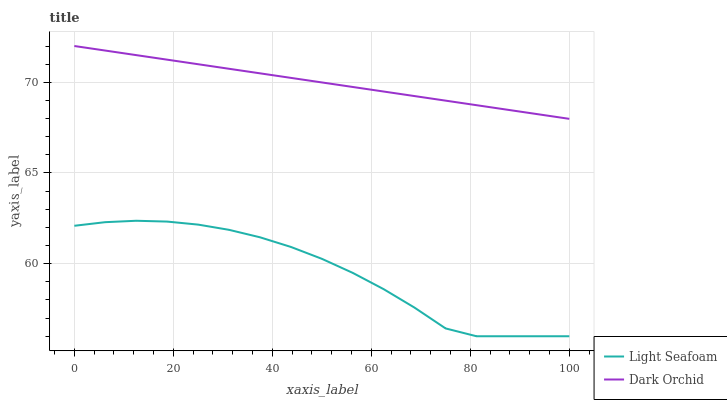Does Light Seafoam have the minimum area under the curve?
Answer yes or no. Yes. Does Dark Orchid have the maximum area under the curve?
Answer yes or no. Yes. Does Dark Orchid have the minimum area under the curve?
Answer yes or no. No. Is Dark Orchid the smoothest?
Answer yes or no. Yes. Is Light Seafoam the roughest?
Answer yes or no. Yes. Is Dark Orchid the roughest?
Answer yes or no. No. Does Light Seafoam have the lowest value?
Answer yes or no. Yes. Does Dark Orchid have the lowest value?
Answer yes or no. No. Does Dark Orchid have the highest value?
Answer yes or no. Yes. Is Light Seafoam less than Dark Orchid?
Answer yes or no. Yes. Is Dark Orchid greater than Light Seafoam?
Answer yes or no. Yes. Does Light Seafoam intersect Dark Orchid?
Answer yes or no. No. 